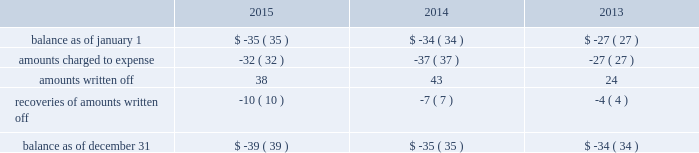Note 4 : property , plant and equipment the table summarizes the major classes of property , plant and equipment by category as of december 31 : 2015 2014 range of remaining useful weighted average useful life utility plant : land and other non-depreciable assets .
$ 141 $ 137 sources of supply .
705 681 12 to 127 years 51 years treatment and pumping facilities .
3070 2969 3 to 101 years 39 years transmission and distribution facilities .
8516 7963 9 to 156 years 83 years services , meters and fire hydrants .
3250 3062 8 to 93 years 35 years general structures and equipment .
1227 1096 1 to 154 years 39 years waste treatment , pumping and disposal .
313 281 2 to 115 years 46 years waste collection .
473 399 5 to 109 years 56 years construction work in progress .
404 303 total utility plant .
18099 16891 nonutility property .
405 378 3 to 50 years 6 years total property , plant and equipment .
$ 18504 $ 17269 property , plant and equipment depreciation expense amounted to $ 405 , $ 392 , and $ 374 for the years ended december 31 , 2015 , 2014 and 2013 , respectively and was included in depreciation and amortization expense in the accompanying consolidated statements of operations .
The provision for depreciation expressed as a percentage of the aggregate average depreciable asset balances was 3.13% ( 3.13 % ) for the year ended december 31 , 2015 and 3.20% ( 3.20 % ) for years december 31 , 2014 and 2013 .
Note 5 : allowance for uncollectible accounts the table summarizes the changes in the company 2019s allowances for uncollectible accounts for the years ended december 31: .

By how much did property , plant and equipment depreciation expense increase from 2013 to 2015? 
Computations: ((405 - 374) / 374)
Answer: 0.08289. Note 4 : property , plant and equipment the table summarizes the major classes of property , plant and equipment by category as of december 31 : 2015 2014 range of remaining useful weighted average useful life utility plant : land and other non-depreciable assets .
$ 141 $ 137 sources of supply .
705 681 12 to 127 years 51 years treatment and pumping facilities .
3070 2969 3 to 101 years 39 years transmission and distribution facilities .
8516 7963 9 to 156 years 83 years services , meters and fire hydrants .
3250 3062 8 to 93 years 35 years general structures and equipment .
1227 1096 1 to 154 years 39 years waste treatment , pumping and disposal .
313 281 2 to 115 years 46 years waste collection .
473 399 5 to 109 years 56 years construction work in progress .
404 303 total utility plant .
18099 16891 nonutility property .
405 378 3 to 50 years 6 years total property , plant and equipment .
$ 18504 $ 17269 property , plant and equipment depreciation expense amounted to $ 405 , $ 392 , and $ 374 for the years ended december 31 , 2015 , 2014 and 2013 , respectively and was included in depreciation and amortization expense in the accompanying consolidated statements of operations .
The provision for depreciation expressed as a percentage of the aggregate average depreciable asset balances was 3.13% ( 3.13 % ) for the year ended december 31 , 2015 and 3.20% ( 3.20 % ) for years december 31 , 2014 and 2013 .
Note 5 : allowance for uncollectible accounts the table summarizes the changes in the company 2019s allowances for uncollectible accounts for the years ended december 31: .

By how much did property , plant and equipment depreciation expense increase from 2013 to 2015? 
Computations: ((405 - 374) / 374)
Answer: 0.08289. 